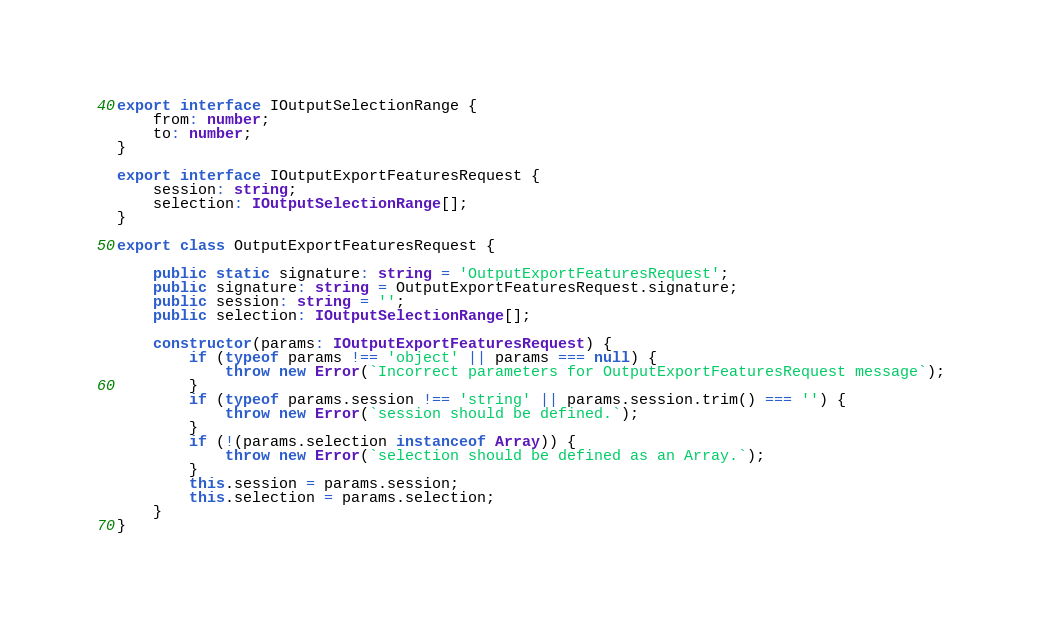<code> <loc_0><loc_0><loc_500><loc_500><_TypeScript_>export interface IOutputSelectionRange {
    from: number;
    to: number;
}

export interface IOutputExportFeaturesRequest {
    session: string;
    selection: IOutputSelectionRange[];
}

export class OutputExportFeaturesRequest {

    public static signature: string = 'OutputExportFeaturesRequest';
    public signature: string = OutputExportFeaturesRequest.signature;
    public session: string = '';
    public selection: IOutputSelectionRange[];

    constructor(params: IOutputExportFeaturesRequest) {
        if (typeof params !== 'object' || params === null) {
            throw new Error(`Incorrect parameters for OutputExportFeaturesRequest message`);
        }
        if (typeof params.session !== 'string' || params.session.trim() === '') {
            throw new Error(`session should be defined.`);
        }
        if (!(params.selection instanceof Array)) {
            throw new Error(`selection should be defined as an Array.`);
        }
        this.session = params.session;
        this.selection = params.selection;
    }
}
</code> 